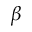Convert formula to latex. <formula><loc_0><loc_0><loc_500><loc_500>\beta</formula> 